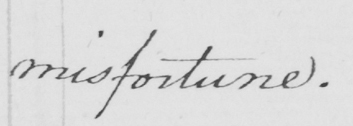What text is written in this handwritten line? misfortune . 